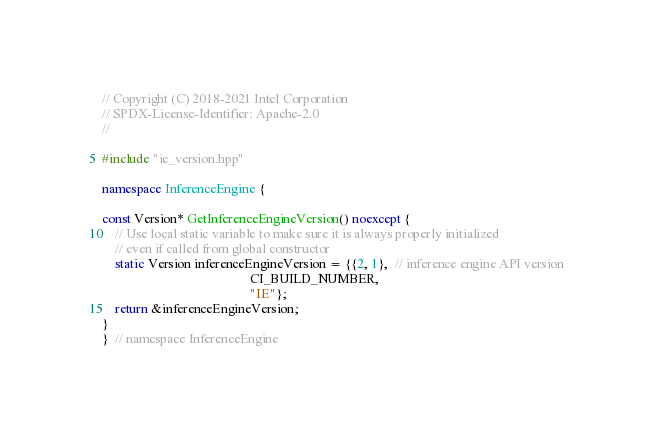<code> <loc_0><loc_0><loc_500><loc_500><_C++_>// Copyright (C) 2018-2021 Intel Corporation
// SPDX-License-Identifier: Apache-2.0
//

#include "ie_version.hpp"

namespace InferenceEngine {

const Version* GetInferenceEngineVersion() noexcept {
    // Use local static variable to make sure it is always properly initialized
    // even if called from global constructor
    static Version inferenceEngineVersion = {{2, 1},  // inference engine API version
                                             CI_BUILD_NUMBER,
                                             "IE"};
    return &inferenceEngineVersion;
}
}  // namespace InferenceEngine
</code> 